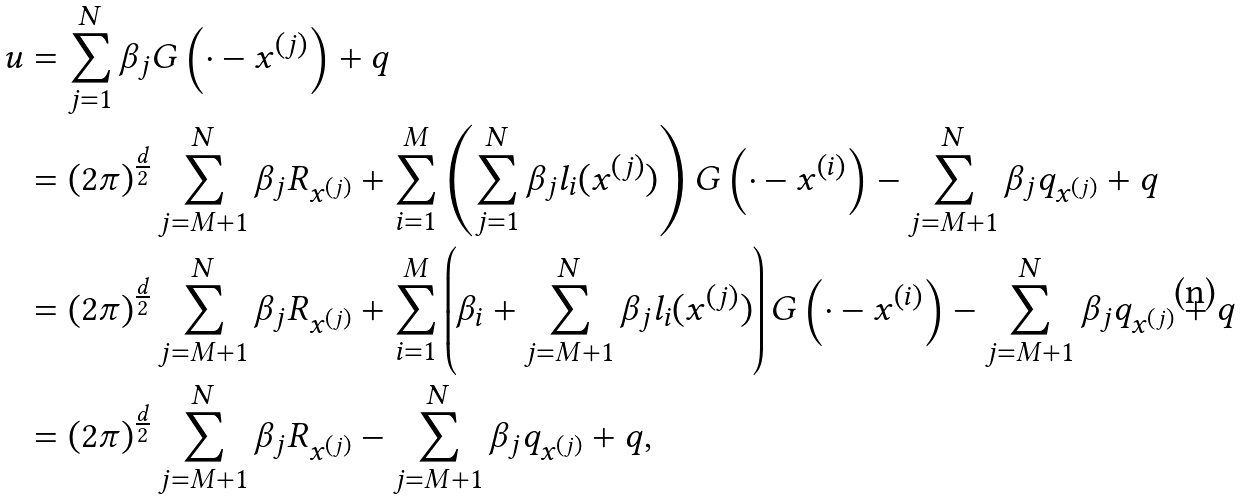Convert formula to latex. <formula><loc_0><loc_0><loc_500><loc_500>u & = \sum _ { j = 1 } ^ { N } \beta _ { j } G \left ( \cdot - x ^ { \left ( j \right ) } \right ) + q \\ & = \left ( 2 \pi \right ) ^ { \frac { d } { 2 } } \sum _ { j = M + 1 } ^ { N } \beta _ { j } R _ { x ^ { \left ( j \right ) } } + \sum _ { i = 1 } ^ { M } \left ( \sum _ { j = 1 } ^ { N } \beta _ { j } l _ { i } ( x ^ { \left ( j \right ) } ) \right ) G \left ( \cdot - x ^ { \left ( i \right ) } \right ) - \sum _ { j = M + 1 } ^ { N } \beta _ { j } q _ { x ^ { \left ( j \right ) } } + q \\ & = \left ( 2 \pi \right ) ^ { \frac { d } { 2 } } \sum _ { j = M + 1 } ^ { N } \beta _ { j } R _ { x ^ { \left ( j \right ) } } + \sum _ { i = 1 } ^ { M } \left ( \beta _ { i } + \sum _ { j = M + 1 } ^ { N } \beta _ { j } l _ { i } ( x ^ { \left ( j \right ) } ) \right ) G \left ( \cdot - x ^ { \left ( i \right ) } \right ) - \sum _ { j = M + 1 } ^ { N } \beta _ { j } q _ { x ^ { \left ( j \right ) } } + q \\ & = \left ( 2 \pi \right ) ^ { \frac { d } { 2 } } \sum _ { j = M + 1 } ^ { N } \beta _ { j } R _ { x ^ { \left ( j \right ) } } - \sum _ { j = M + 1 } ^ { N } \beta _ { j } q _ { x ^ { \left ( j \right ) } } + q ,</formula> 